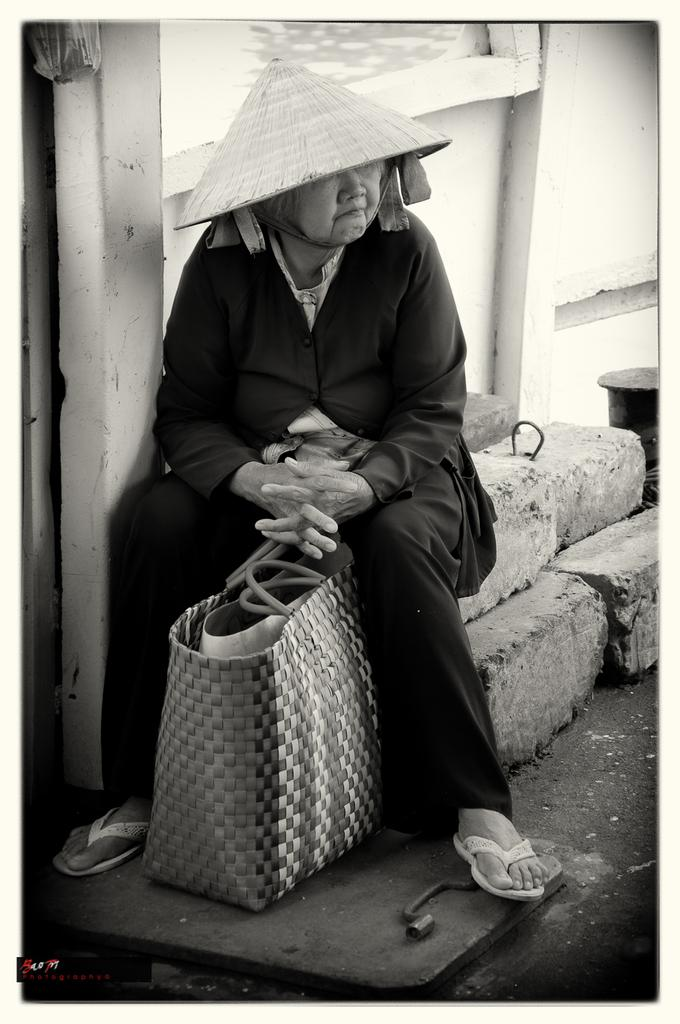Who or what is present in the image? There is a person in the image. What is the person wearing on their head? The person is wearing a hat. Where is the person sitting? The person is sitting on stones. What is located beside the person? There is a wall beside the person. What object is near the person? There is a basket near the person. Can you see a tiger roaring in the image? No, there is no tiger present in the image. Is the person holding an engine in the image? No, there is no engine present in the image. 